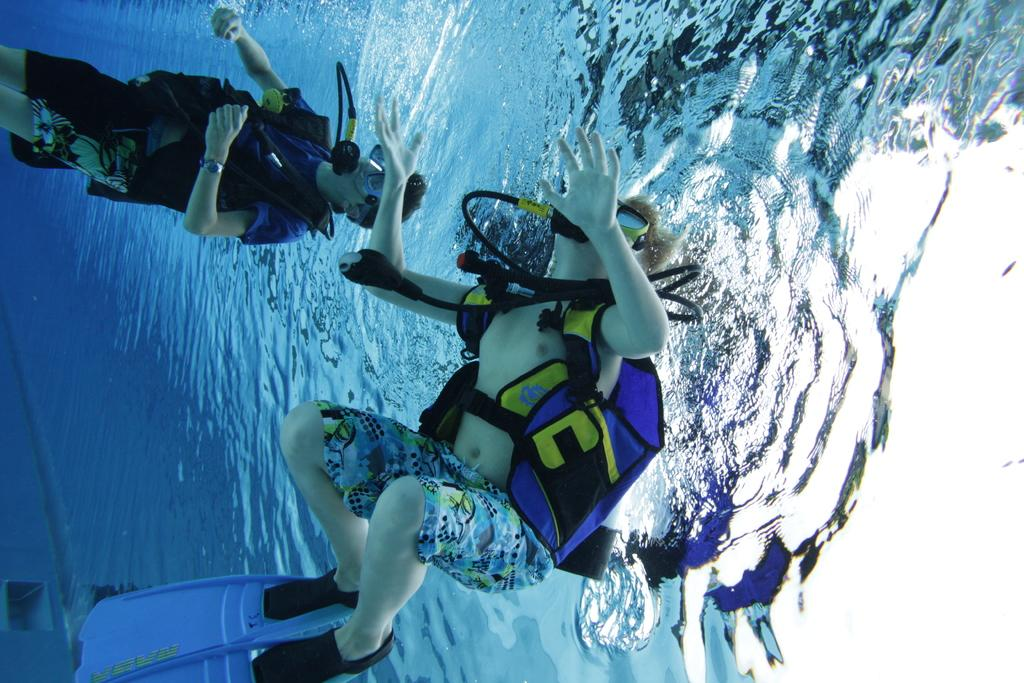What are the people in the image doing? The people in the image are in the water. Can you describe the setting or location of the image? The provided facts do not give enough information to describe the setting or location of the image. Are there any objects or animals present in the image besides the people? The provided facts do not mention any objects or animals besides the people. How many dogs are wearing collars in the image? There are no dogs or collars present in the image; it features people in the water. 